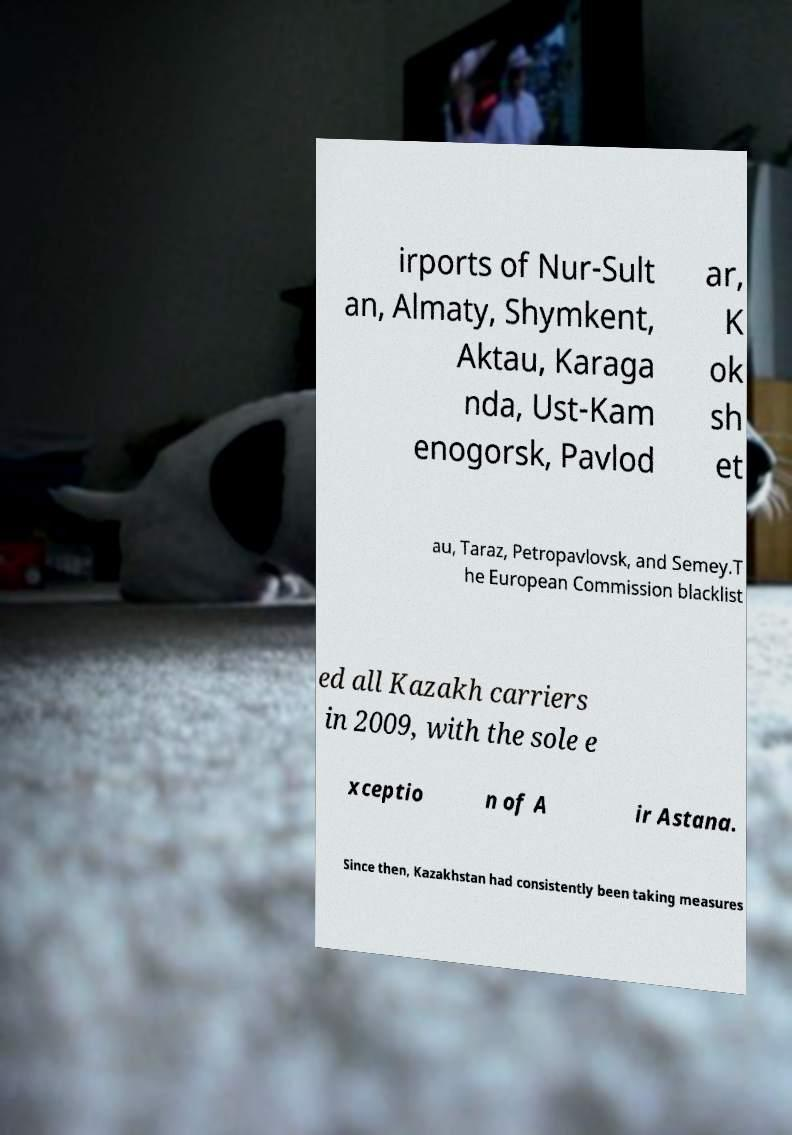What messages or text are displayed in this image? I need them in a readable, typed format. irports of Nur-Sult an, Almaty, Shymkent, Aktau, Karaga nda, Ust-Kam enogorsk, Pavlod ar, K ok sh et au, Taraz, Petropavlovsk, and Semey.T he European Commission blacklist ed all Kazakh carriers in 2009, with the sole e xceptio n of A ir Astana. Since then, Kazakhstan had consistently been taking measures 